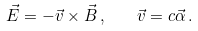<formula> <loc_0><loc_0><loc_500><loc_500>\vec { E } = - \vec { v } \times \vec { B } \, , \quad \vec { v } = c \vec { \alpha } \, .</formula> 